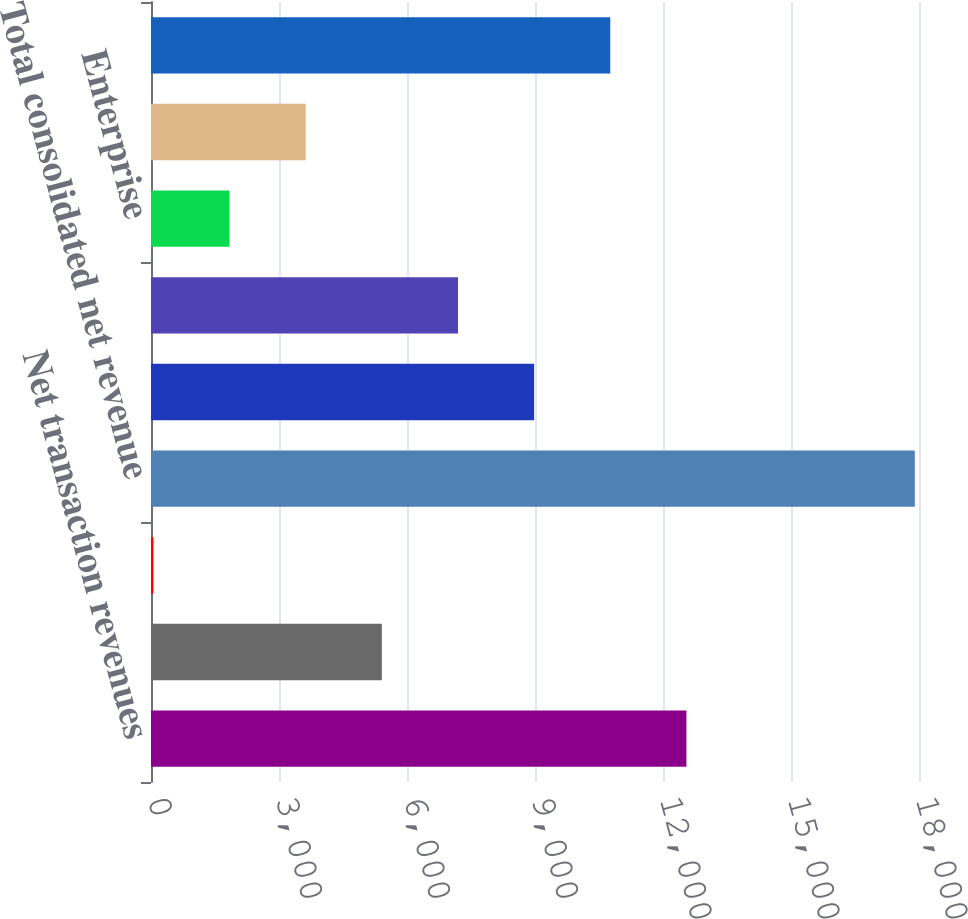<chart> <loc_0><loc_0><loc_500><loc_500><bar_chart><fcel>Net transaction revenues<fcel>Marketing services and other<fcel>Elimination of inter-segment<fcel>Total consolidated net revenue<fcel>Marketplaces<fcel>Payments<fcel>Enterprise<fcel>Corporate and other<fcel>Total operating income (loss)<nl><fcel>12548.5<fcel>5410.5<fcel>57<fcel>17902<fcel>8979.5<fcel>7195<fcel>1841.5<fcel>3626<fcel>10764<nl></chart> 